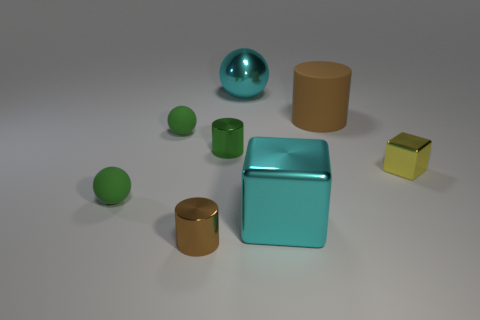What number of other things are there of the same material as the large brown object
Provide a succinct answer. 2. There is a big shiny thing that is the same color as the metallic sphere; what shape is it?
Keep it short and to the point. Cube. There is a cyan shiny object in front of the brown matte object; what is its size?
Give a very brief answer. Large. What shape is the brown object that is the same material as the green cylinder?
Provide a short and direct response. Cylinder. Do the tiny cube and the brown cylinder that is to the right of the tiny green metal thing have the same material?
Keep it short and to the point. No. Is the shape of the large cyan metallic object that is on the left side of the cyan cube the same as  the big matte thing?
Provide a short and direct response. No. What is the material of the cyan thing that is the same shape as the tiny yellow object?
Provide a succinct answer. Metal. There is a tiny yellow shiny thing; is its shape the same as the big object behind the big cylinder?
Ensure brevity in your answer.  No. There is a matte object that is behind the tiny yellow metal thing and left of the big cyan metallic ball; what is its color?
Ensure brevity in your answer.  Green. Are there any green cylinders?
Offer a terse response. Yes. 